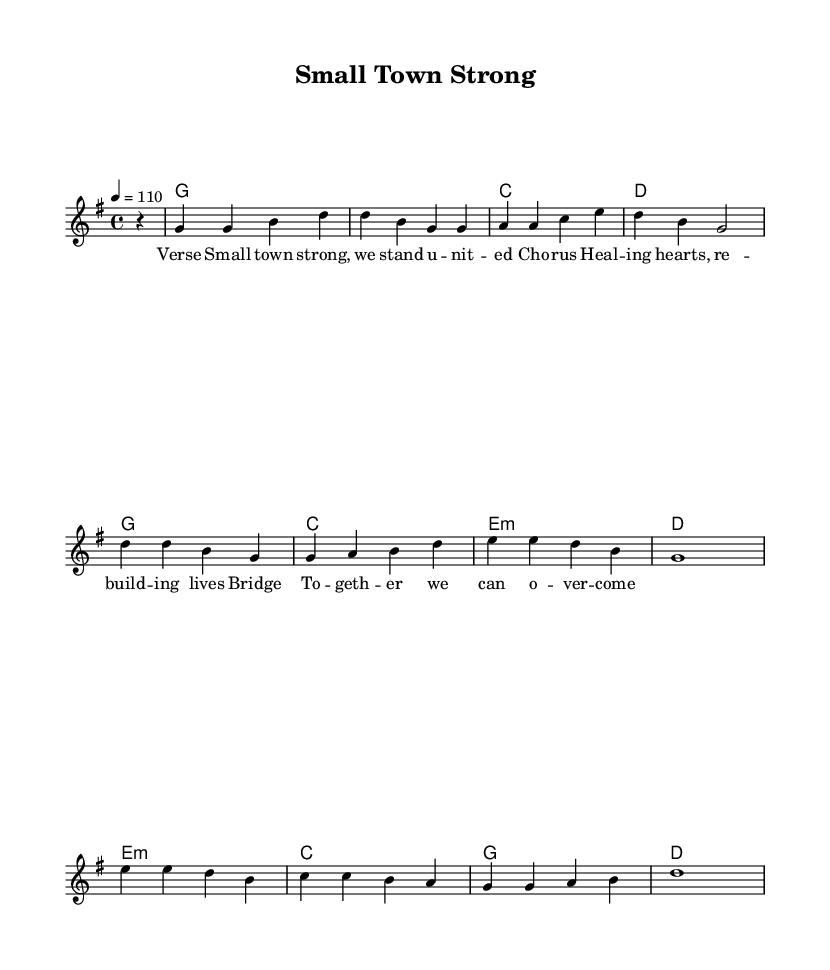What is the key signature of this music? The key signature is G major, which has one sharp, indicated by the presence of an F# in the staff.
Answer: G major What is the time signature of the piece? The time signature is 4/4, indicated at the beginning of the score, showing that there are four beats per measure.
Answer: 4/4 What is the tempo marking for the music? The tempo marking is 110 beats per minute, given at the start of the piece, indicating how fast the music should be played.
Answer: 110 How many measures are in the melody? The melody consists of 8 measures, visually represented by the number of repeated groupings of musical notes and rests in the score.
Answer: 8 What is the first chord in the harmony? The first chord indicated in the harmony part is G major, shown at the beginning of the score as the first entry in the chord names.
Answer: G Which lyric section addresses community support? The lyric section "To -- geth -- er we can o -- ver -- come" explicitly refers to community support and unity to overcome challenges, as highlighted in the provided lyrics.
Answer: "To -- geth -- er we can o -- ver -- come" 